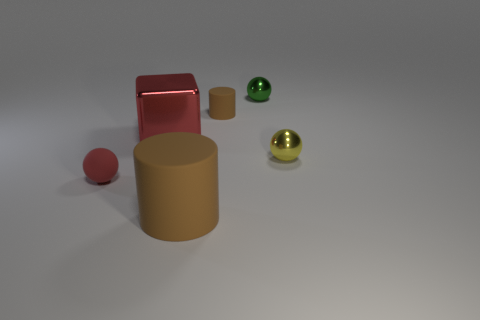Subtract all rubber balls. How many balls are left? 2 Subtract all green balls. How many balls are left? 2 Subtract all cubes. How many objects are left? 5 Add 2 green objects. How many objects exist? 8 Subtract all cyan cubes. Subtract all gray cylinders. How many cubes are left? 1 Subtract all red rubber things. Subtract all tiny rubber cylinders. How many objects are left? 4 Add 6 cubes. How many cubes are left? 7 Add 2 tiny brown things. How many tiny brown things exist? 3 Subtract 0 green cylinders. How many objects are left? 6 Subtract 2 spheres. How many spheres are left? 1 